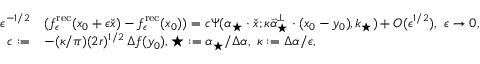<formula> <loc_0><loc_0><loc_500><loc_500>\begin{array} { r l } { \epsilon ^ { - 1 / 2 } } & { ( f _ { \epsilon } ^ { r e c } ( x _ { 0 } + \epsilon \check { x } ) - f _ { \epsilon } ^ { r e c } ( x _ { 0 } ) ) = c \Psi ( \alpha _ { ^ { * } } \cdot \check { x } ; \kappa \vec { \alpha } _ { ^ { * } } ^ { \perp } \cdot ( x _ { 0 } - y _ { 0 } ) , k _ { ^ { * } } ) + O ( \epsilon ^ { 1 / 2 } ) , \ \epsilon \to 0 , } \\ { c \colon = } & { - ( \kappa / \pi ) ( 2 r ) ^ { 1 / 2 } \, \Delta f ( y _ { 0 } ) , \ k _ { ^ { * } } \colon = \alpha _ { ^ { * } } / \Delta \alpha , \ \kappa \colon = \Delta \alpha / \epsilon , } \end{array}</formula> 